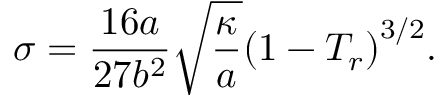Convert formula to latex. <formula><loc_0><loc_0><loc_500><loc_500>\sigma = \frac { 1 6 a } { 2 7 b ^ { 2 } } \sqrt { \frac { \kappa } { a } } { \left ( 1 - T _ { r } \right ) } ^ { 3 / 2 } .</formula> 